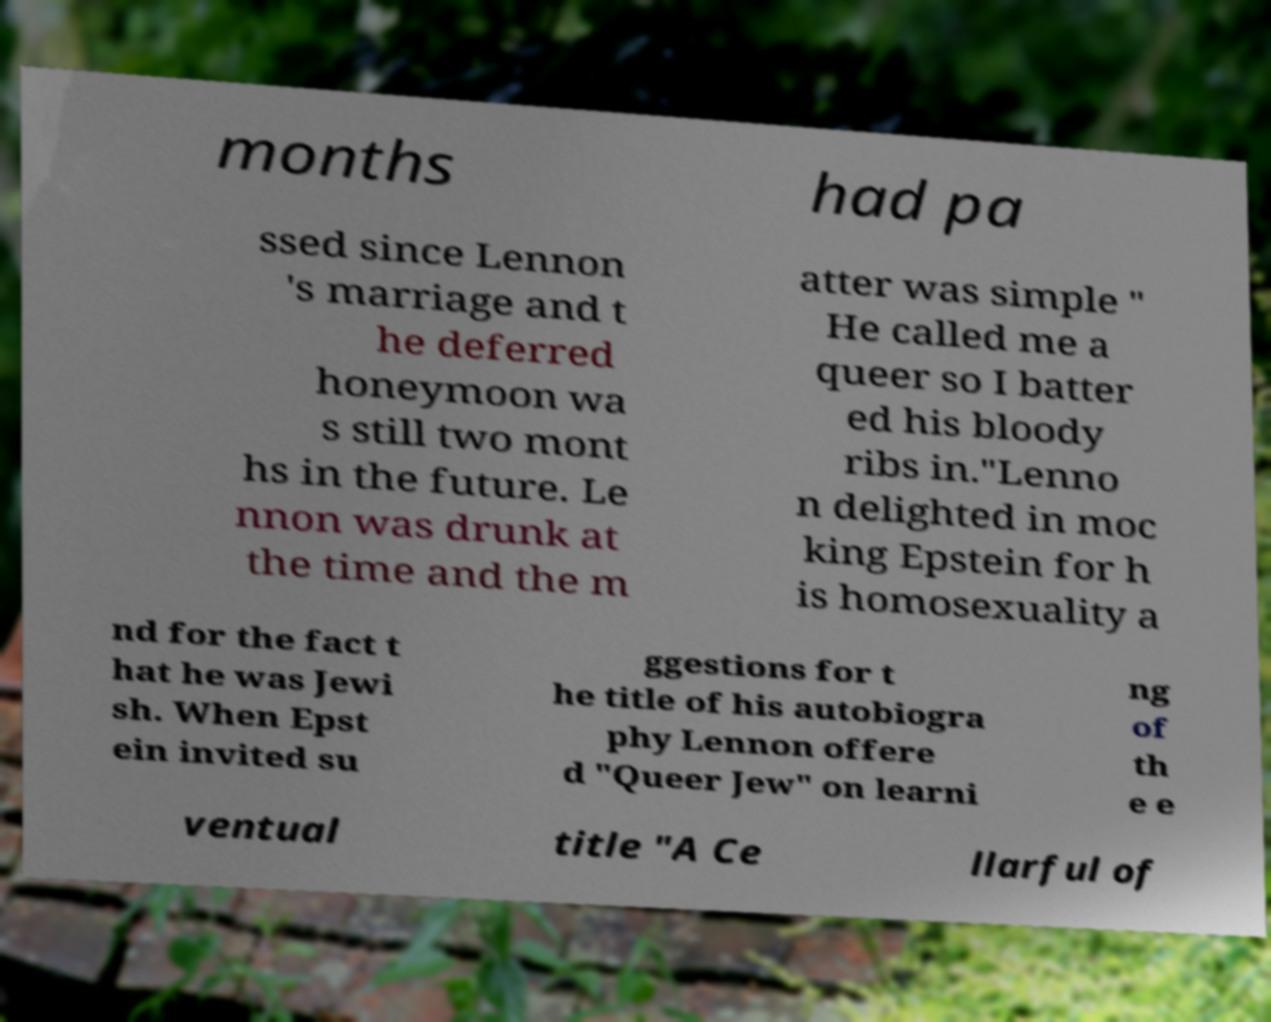What messages or text are displayed in this image? I need them in a readable, typed format. months had pa ssed since Lennon 's marriage and t he deferred honeymoon wa s still two mont hs in the future. Le nnon was drunk at the time and the m atter was simple " He called me a queer so I batter ed his bloody ribs in."Lenno n delighted in moc king Epstein for h is homosexuality a nd for the fact t hat he was Jewi sh. When Epst ein invited su ggestions for t he title of his autobiogra phy Lennon offere d "Queer Jew" on learni ng of th e e ventual title "A Ce llarful of 